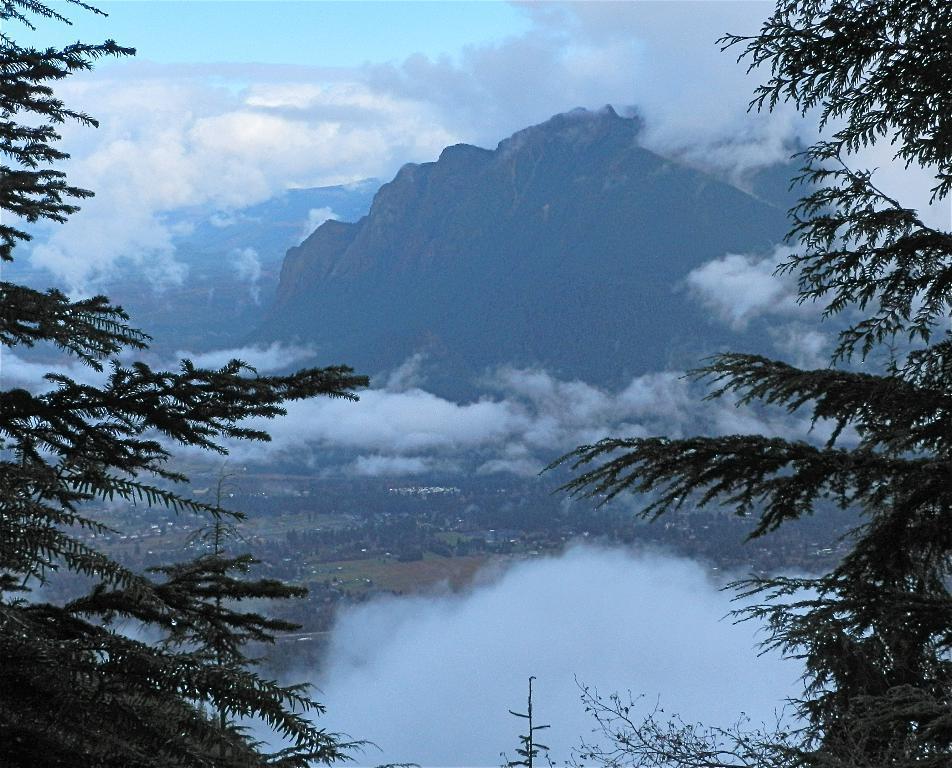Can you describe this image briefly? There are trees on the sides. In the background there are clouds, hills and sky. 